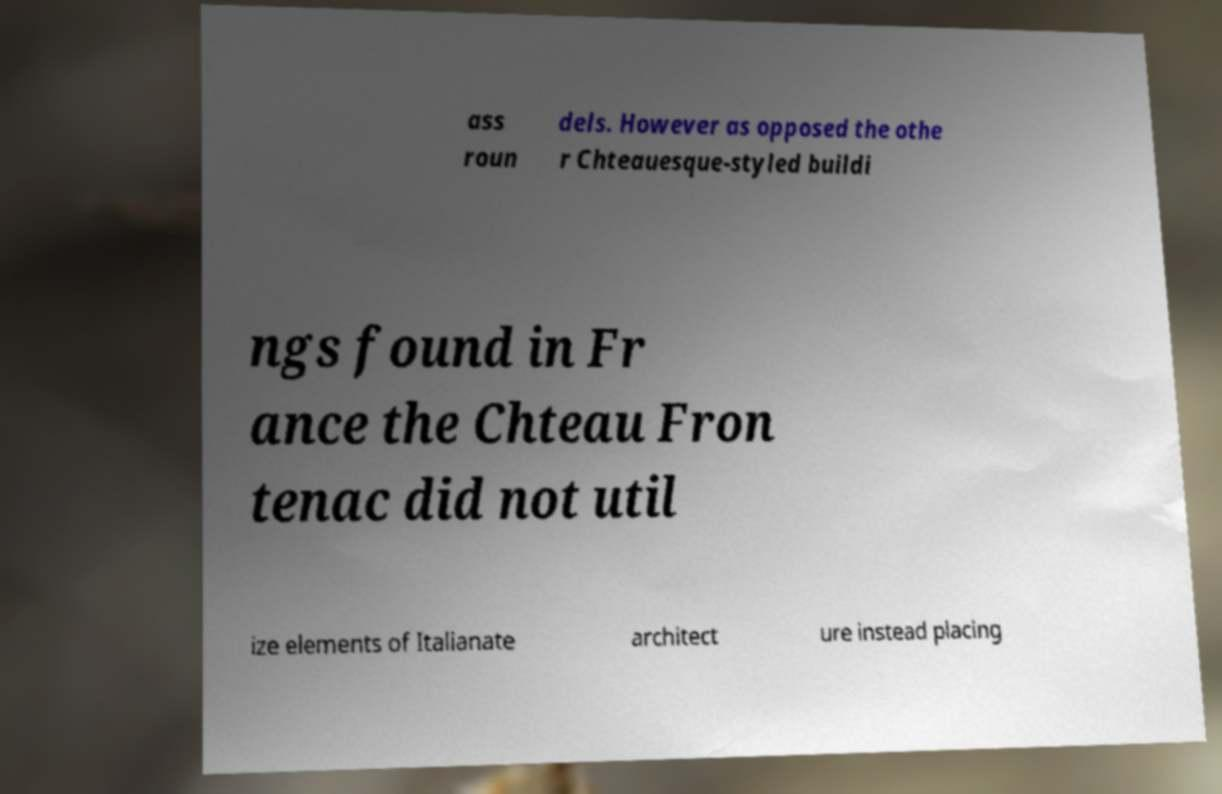Could you assist in decoding the text presented in this image and type it out clearly? ass roun dels. However as opposed the othe r Chteauesque-styled buildi ngs found in Fr ance the Chteau Fron tenac did not util ize elements of Italianate architect ure instead placing 